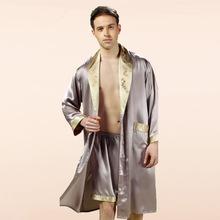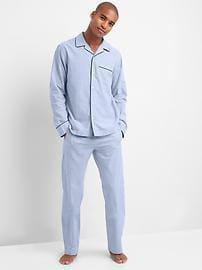The first image is the image on the left, the second image is the image on the right. Assess this claim about the two images: "in one of the images, a man is holding on to the front of his clothing with one hand". Correct or not? Answer yes or no. Yes. The first image is the image on the left, the second image is the image on the right. Given the left and right images, does the statement "the mans feet can be seen in the right pic" hold true? Answer yes or no. Yes. 